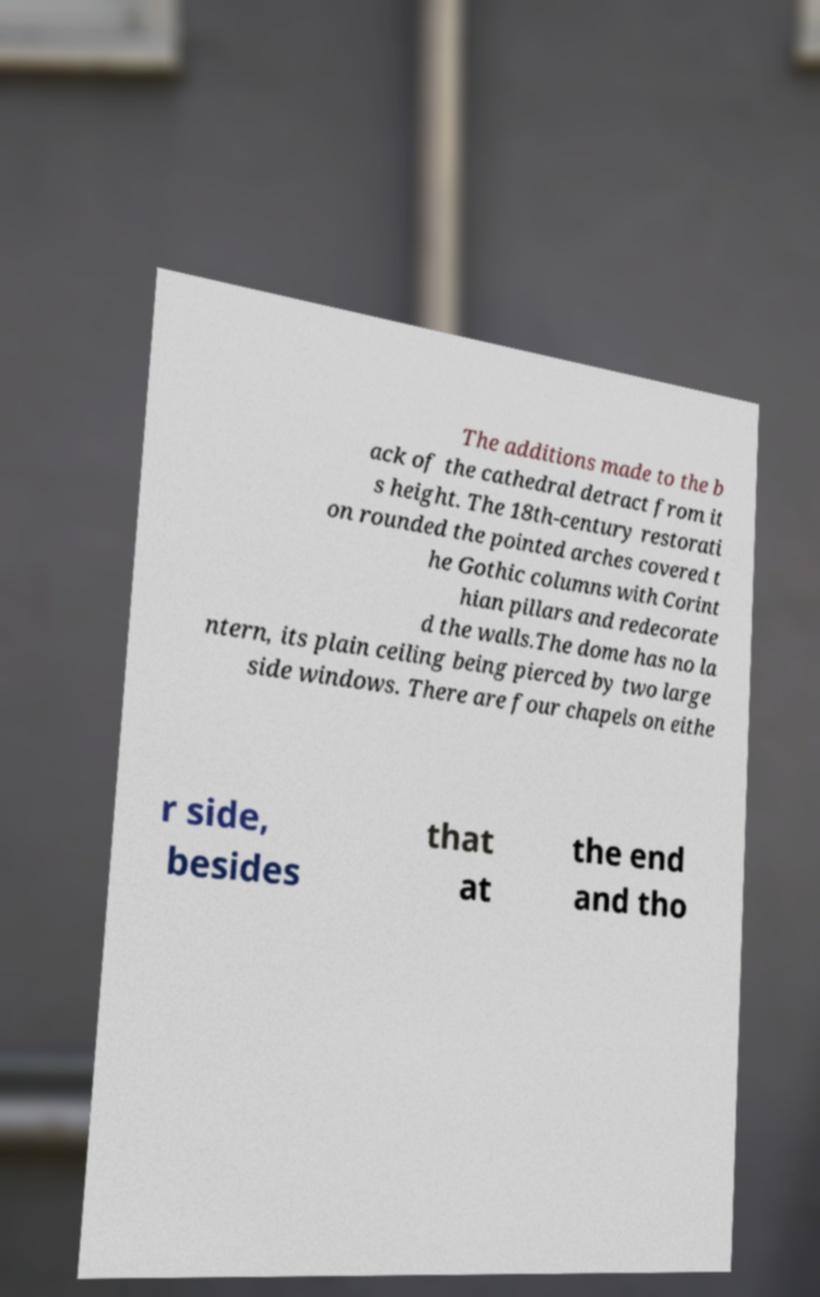I need the written content from this picture converted into text. Can you do that? The additions made to the b ack of the cathedral detract from it s height. The 18th-century restorati on rounded the pointed arches covered t he Gothic columns with Corint hian pillars and redecorate d the walls.The dome has no la ntern, its plain ceiling being pierced by two large side windows. There are four chapels on eithe r side, besides that at the end and tho 